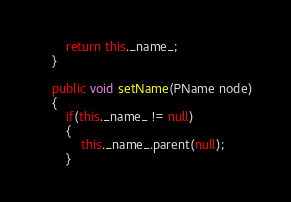<code> <loc_0><loc_0><loc_500><loc_500><_Java_>        return this._name_;
    }

    public void setName(PName node)
    {
        if(this._name_ != null)
        {
            this._name_.parent(null);
        }
</code> 